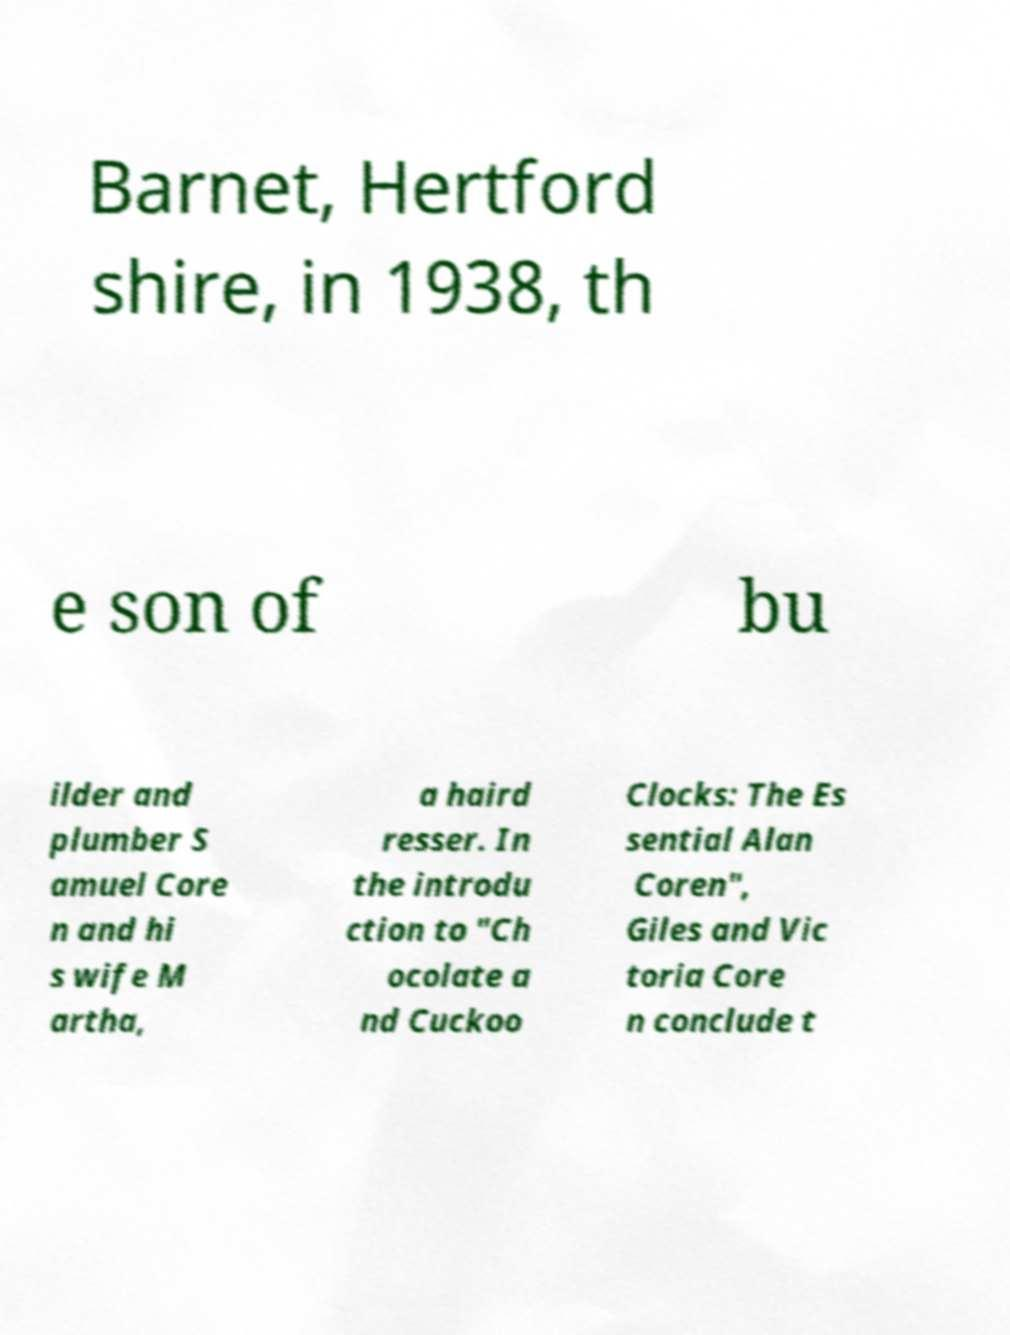Can you accurately transcribe the text from the provided image for me? Barnet, Hertford shire, in 1938, th e son of bu ilder and plumber S amuel Core n and hi s wife M artha, a haird resser. In the introdu ction to "Ch ocolate a nd Cuckoo Clocks: The Es sential Alan Coren", Giles and Vic toria Core n conclude t 